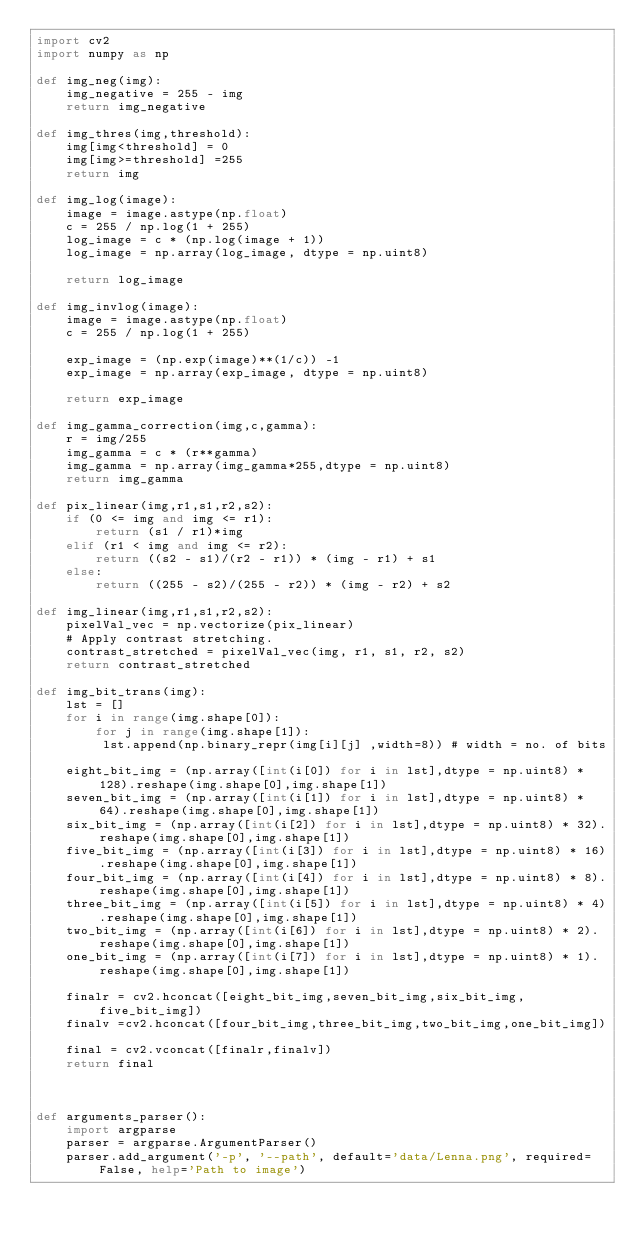Convert code to text. <code><loc_0><loc_0><loc_500><loc_500><_Python_>import cv2
import numpy as np

def img_neg(img):
    img_negative = 255 - img
    return img_negative

def img_thres(img,threshold):
    img[img<threshold] = 0
    img[img>=threshold] =255
    return img

def img_log(image):
    image = image.astype(np.float)
    c = 255 / np.log(1 + 255)
    log_image = c * (np.log(image + 1)) 
    log_image = np.array(log_image, dtype = np.uint8) 
    
    return log_image

def img_invlog(image):
    image = image.astype(np.float)
    c = 255 / np.log(1 + 255) 
    
    exp_image = (np.exp(image)**(1/c)) -1
    exp_image = np.array(exp_image, dtype = np.uint8)
    
    return exp_image

def img_gamma_correction(img,c,gamma):
    r = img/255
    img_gamma = c * (r**gamma)
    img_gamma = np.array(img_gamma*255,dtype = np.uint8)
    return img_gamma

def pix_linear(img,r1,s1,r2,s2):
    if (0 <= img and img <= r1): 
        return (s1 / r1)*img 
    elif (r1 < img and img <= r2): 
        return ((s2 - s1)/(r2 - r1)) * (img - r1) + s1 
    else: 
        return ((255 - s2)/(255 - r2)) * (img - r2) + s2

def img_linear(img,r1,s1,r2,s2):
    pixelVal_vec = np.vectorize(pix_linear)
    # Apply contrast stretching. 
    contrast_stretched = pixelVal_vec(img, r1, s1, r2, s2) 
    return contrast_stretched
    
def img_bit_trans(img):
    lst = []
    for i in range(img.shape[0]):
        for j in range(img.shape[1]):
         lst.append(np.binary_repr(img[i][j] ,width=8)) # width = no. of bits
 
    eight_bit_img = (np.array([int(i[0]) for i in lst],dtype = np.uint8) * 128).reshape(img.shape[0],img.shape[1])
    seven_bit_img = (np.array([int(i[1]) for i in lst],dtype = np.uint8) * 64).reshape(img.shape[0],img.shape[1])
    six_bit_img = (np.array([int(i[2]) for i in lst],dtype = np.uint8) * 32).reshape(img.shape[0],img.shape[1])
    five_bit_img = (np.array([int(i[3]) for i in lst],dtype = np.uint8) * 16).reshape(img.shape[0],img.shape[1])
    four_bit_img = (np.array([int(i[4]) for i in lst],dtype = np.uint8) * 8).reshape(img.shape[0],img.shape[1])
    three_bit_img = (np.array([int(i[5]) for i in lst],dtype = np.uint8) * 4).reshape(img.shape[0],img.shape[1])
    two_bit_img = (np.array([int(i[6]) for i in lst],dtype = np.uint8) * 2).reshape(img.shape[0],img.shape[1])
    one_bit_img = (np.array([int(i[7]) for i in lst],dtype = np.uint8) * 1).reshape(img.shape[0],img.shape[1])
 
    finalr = cv2.hconcat([eight_bit_img,seven_bit_img,six_bit_img,five_bit_img])
    finalv =cv2.hconcat([four_bit_img,three_bit_img,two_bit_img,one_bit_img])
 
    final = cv2.vconcat([finalr,finalv])
    return final



def arguments_parser():
    import argparse
    parser = argparse.ArgumentParser()
    parser.add_argument('-p', '--path', default='data/Lenna.png', required=False, help='Path to image')</code> 